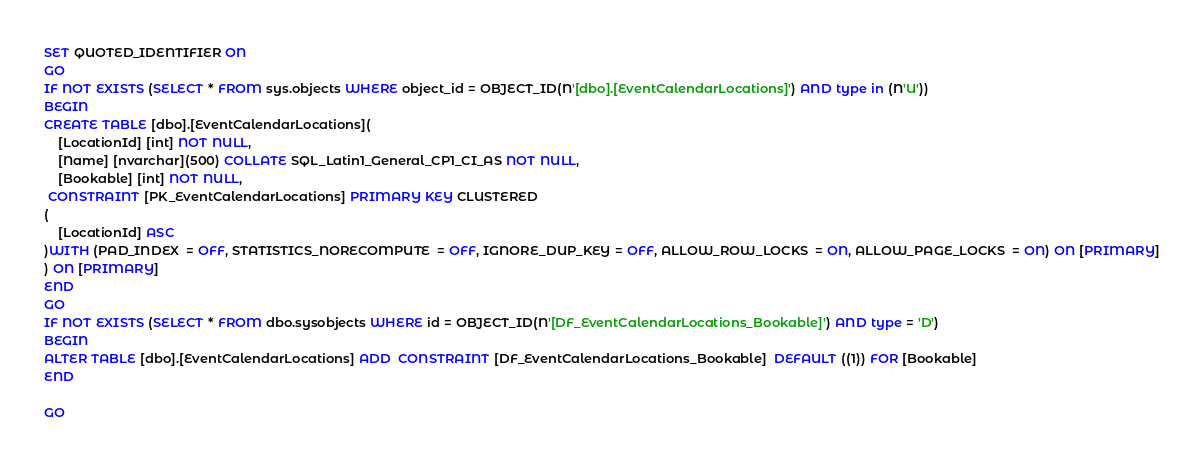Convert code to text. <code><loc_0><loc_0><loc_500><loc_500><_SQL_>SET QUOTED_IDENTIFIER ON
GO
IF NOT EXISTS (SELECT * FROM sys.objects WHERE object_id = OBJECT_ID(N'[dbo].[EventCalendarLocations]') AND type in (N'U'))
BEGIN
CREATE TABLE [dbo].[EventCalendarLocations](
	[LocationId] [int] NOT NULL,
	[Name] [nvarchar](500) COLLATE SQL_Latin1_General_CP1_CI_AS NOT NULL,
	[Bookable] [int] NOT NULL,
 CONSTRAINT [PK_EventCalendarLocations] PRIMARY KEY CLUSTERED 
(
	[LocationId] ASC
)WITH (PAD_INDEX  = OFF, STATISTICS_NORECOMPUTE  = OFF, IGNORE_DUP_KEY = OFF, ALLOW_ROW_LOCKS  = ON, ALLOW_PAGE_LOCKS  = ON) ON [PRIMARY]
) ON [PRIMARY]
END
GO
IF NOT EXISTS (SELECT * FROM dbo.sysobjects WHERE id = OBJECT_ID(N'[DF_EventCalendarLocations_Bookable]') AND type = 'D')
BEGIN
ALTER TABLE [dbo].[EventCalendarLocations] ADD  CONSTRAINT [DF_EventCalendarLocations_Bookable]  DEFAULT ((1)) FOR [Bookable]
END

GO
</code> 